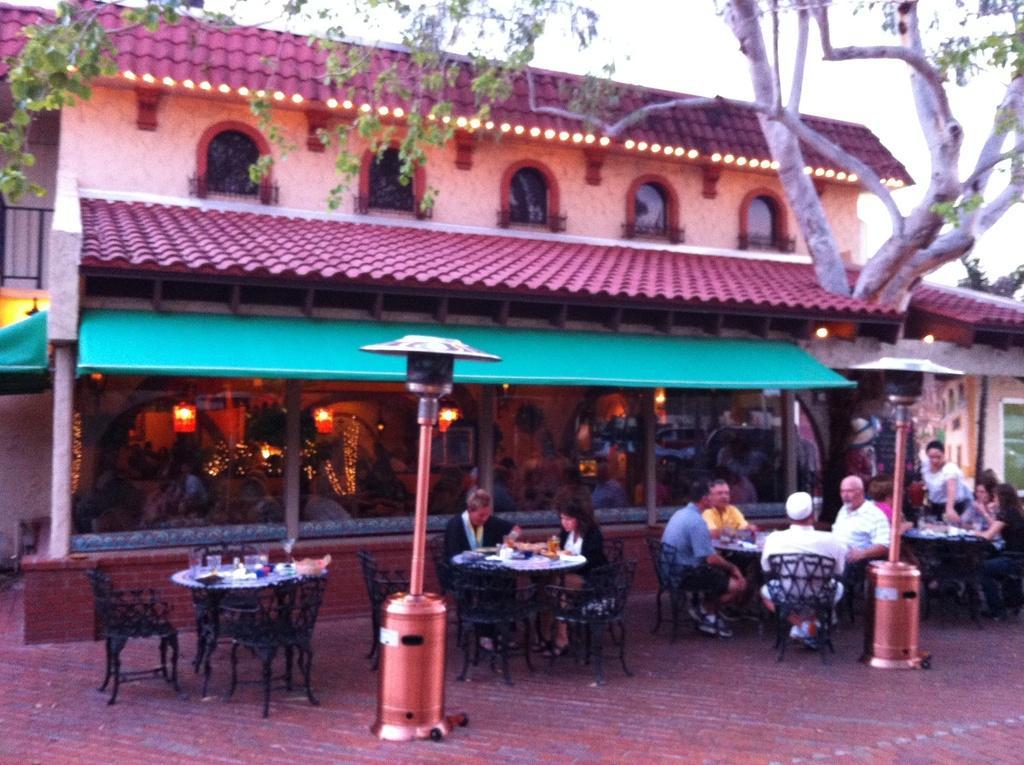Could you give a brief overview of what you see in this image? In this image I can see the group of people sitting on the chairs and these people are in front of the building. There is also a tree and a sky. 